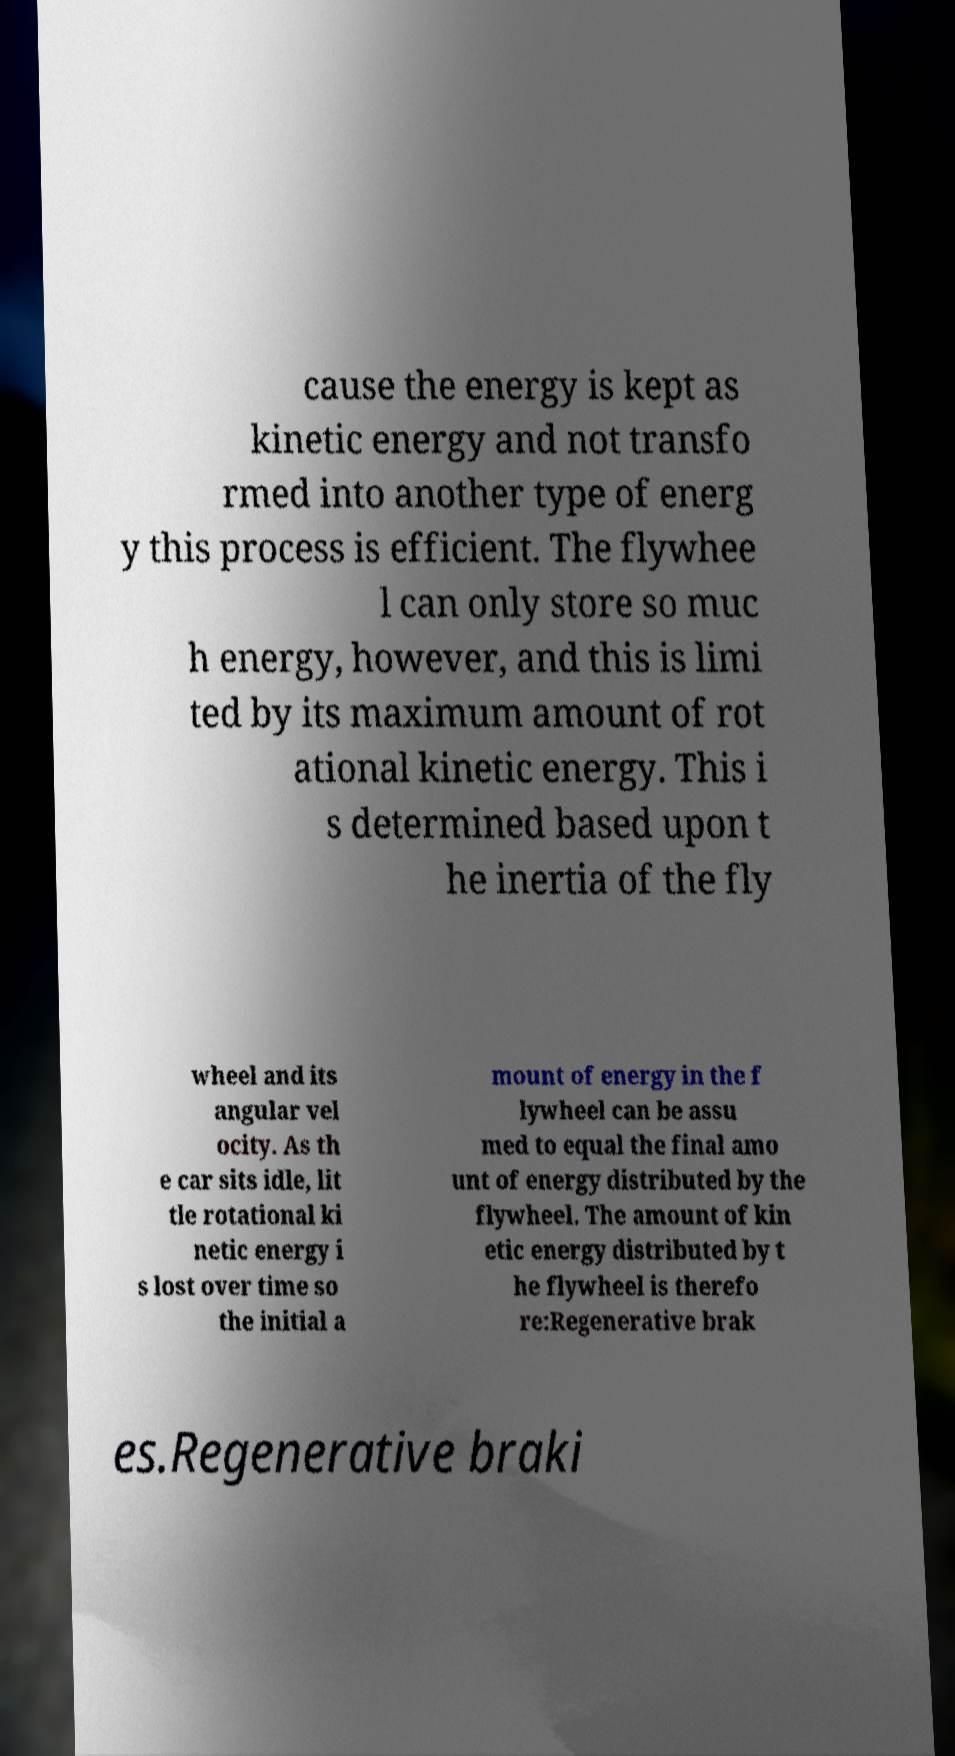What messages or text are displayed in this image? I need them in a readable, typed format. cause the energy is kept as kinetic energy and not transfo rmed into another type of energ y this process is efficient. The flywhee l can only store so muc h energy, however, and this is limi ted by its maximum amount of rot ational kinetic energy. This i s determined based upon t he inertia of the fly wheel and its angular vel ocity. As th e car sits idle, lit tle rotational ki netic energy i s lost over time so the initial a mount of energy in the f lywheel can be assu med to equal the final amo unt of energy distributed by the flywheel. The amount of kin etic energy distributed by t he flywheel is therefo re:Regenerative brak es.Regenerative braki 